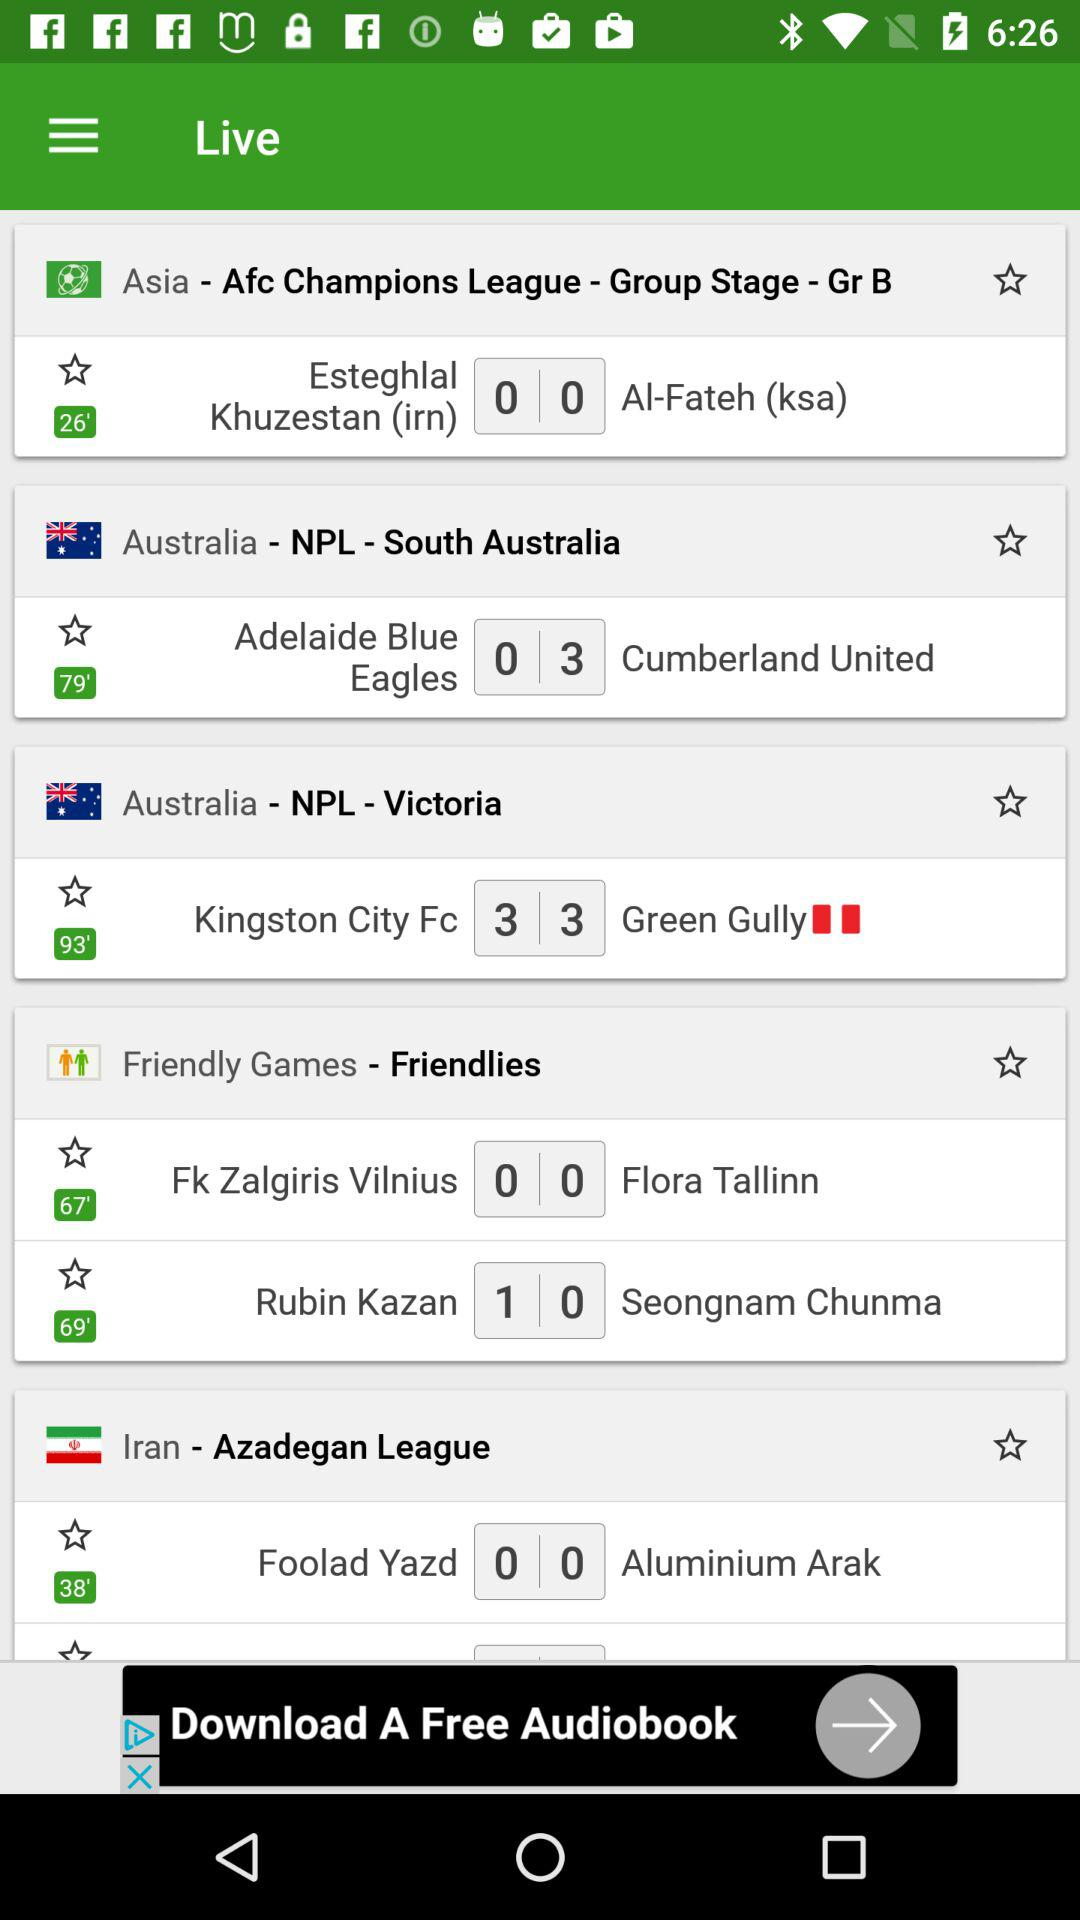What league is played in Iran? The league played in Iran is the "Azadegan League". 